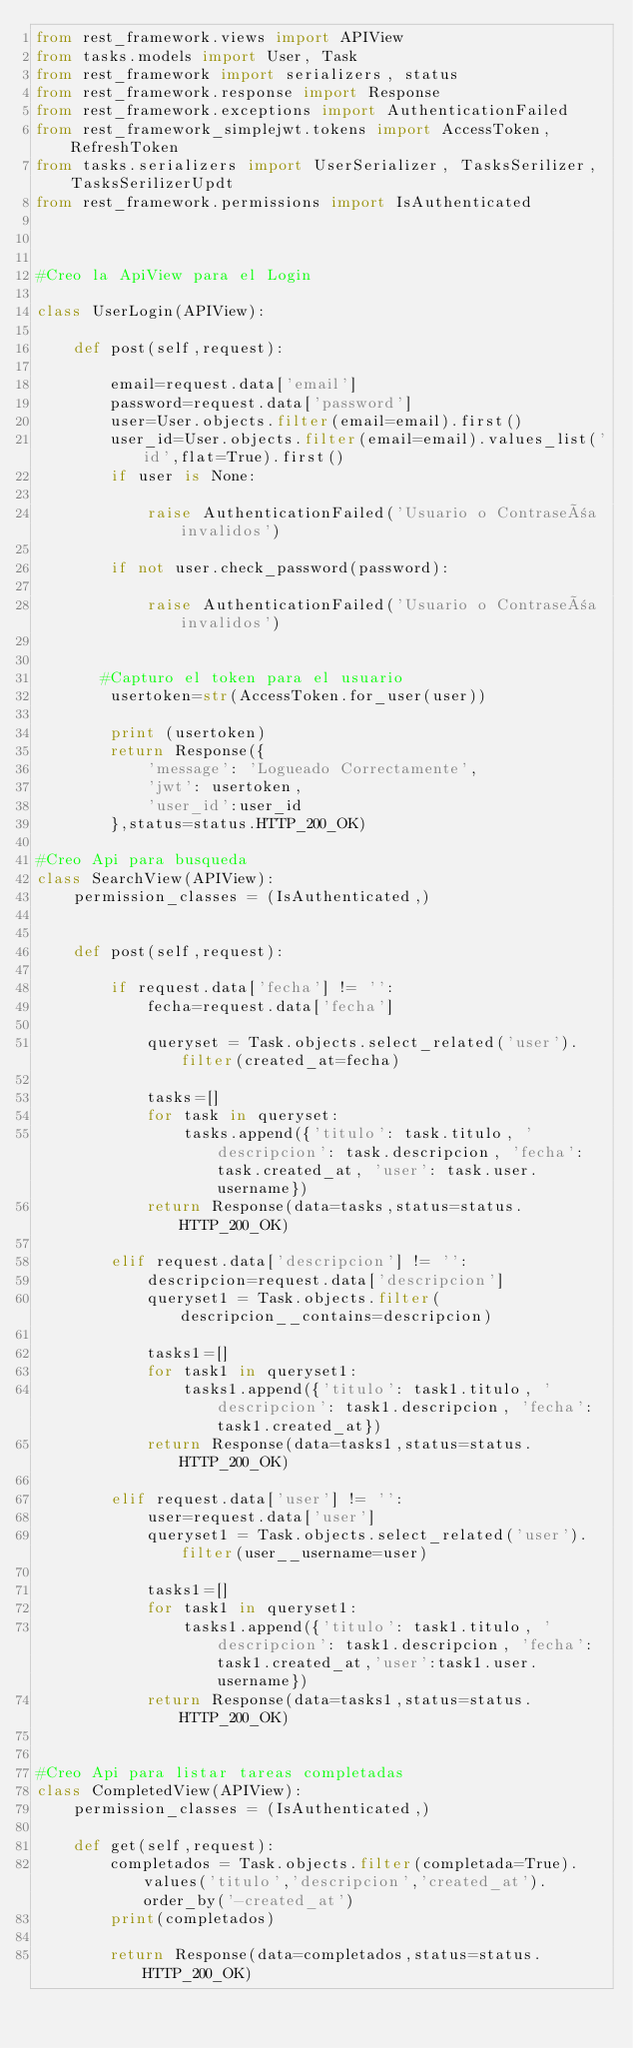<code> <loc_0><loc_0><loc_500><loc_500><_Python_>from rest_framework.views import APIView
from tasks.models import User, Task
from rest_framework import serializers, status
from rest_framework.response import Response
from rest_framework.exceptions import AuthenticationFailed
from rest_framework_simplejwt.tokens import AccessToken,RefreshToken
from tasks.serializers import UserSerializer, TasksSerilizer, TasksSerilizerUpdt
from rest_framework.permissions import IsAuthenticated



#Creo la ApiView para el Login

class UserLogin(APIView):

    def post(self,request):

        email=request.data['email']
        password=request.data['password']
        user=User.objects.filter(email=email).first()
        user_id=User.objects.filter(email=email).values_list('id',flat=True).first()
        if user is None:

            raise AuthenticationFailed('Usuario o Contraseña invalidos')

        if not user.check_password(password):

            raise AuthenticationFailed('Usuario o Contraseña invalidos')

    
       #Capturo el token para el usuario
        usertoken=str(AccessToken.for_user(user))

        print (usertoken)
        return Response({
            'message': 'Logueado Correctamente',
            'jwt': usertoken,
            'user_id':user_id
        },status=status.HTTP_200_OK)

#Creo Api para busqueda
class SearchView(APIView):
    permission_classes = (IsAuthenticated,)
    

    def post(self,request):
     
        if request.data['fecha'] != '':
            fecha=request.data['fecha']
       
            queryset = Task.objects.select_related('user').filter(created_at=fecha)
            
            tasks=[]
            for task in queryset:
                tasks.append({'titulo': task.titulo, 'descripcion': task.descripcion, 'fecha': task.created_at, 'user': task.user.username})
            return Response(data=tasks,status=status.HTTP_200_OK)

        elif request.data['descripcion'] != '':
            descripcion=request.data['descripcion']
            queryset1 = Task.objects.filter(descripcion__contains=descripcion)

            tasks1=[]
            for task1 in queryset1:
                tasks1.append({'titulo': task1.titulo, 'descripcion': task1.descripcion, 'fecha': task1.created_at})
            return Response(data=tasks1,status=status.HTTP_200_OK)

        elif request.data['user'] != '':
            user=request.data['user']
            queryset1 = Task.objects.select_related('user').filter(user__username=user)

            tasks1=[]
            for task1 in queryset1:
                tasks1.append({'titulo': task1.titulo, 'descripcion': task1.descripcion, 'fecha': task1.created_at,'user':task1.user.username})
            return Response(data=tasks1,status=status.HTTP_200_OK)

         
#Creo Api para listar tareas completadas
class CompletedView(APIView):
    permission_classes = (IsAuthenticated,)

    def get(self,request):
        completados = Task.objects.filter(completada=True).values('titulo','descripcion','created_at').order_by('-created_at')
        print(completados)

        return Response(data=completados,status=status.HTTP_200_OK)</code> 